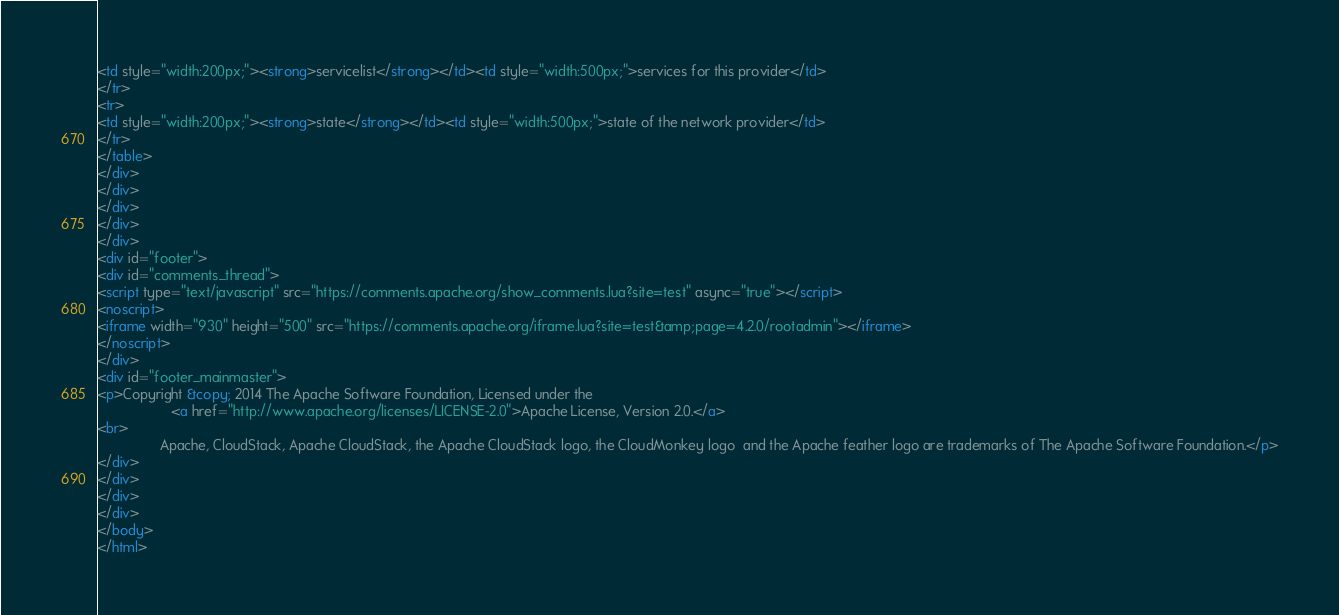Convert code to text. <code><loc_0><loc_0><loc_500><loc_500><_HTML_><td style="width:200px;"><strong>servicelist</strong></td><td style="width:500px;">services for this provider</td>
</tr>
<tr>
<td style="width:200px;"><strong>state</strong></td><td style="width:500px;">state of the network provider</td>
</tr>
</table>
</div>
</div>
</div>
</div>
</div>
<div id="footer">
<div id="comments_thread">
<script type="text/javascript" src="https://comments.apache.org/show_comments.lua?site=test" async="true"></script>
<noscript>
<iframe width="930" height="500" src="https://comments.apache.org/iframe.lua?site=test&amp;page=4.2.0/rootadmin"></iframe>
</noscript>
</div>
<div id="footer_mainmaster">
<p>Copyright &copy; 2014 The Apache Software Foundation, Licensed under the
                   <a href="http://www.apache.org/licenses/LICENSE-2.0">Apache License, Version 2.0.</a>
<br>
                Apache, CloudStack, Apache CloudStack, the Apache CloudStack logo, the CloudMonkey logo  and the Apache feather logo are trademarks of The Apache Software Foundation.</p>
</div>
</div>
</div>
</div>
</body>
</html>
</code> 